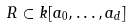<formula> <loc_0><loc_0><loc_500><loc_500>R \subset k [ a _ { 0 } , \dots , a _ { d } ]</formula> 